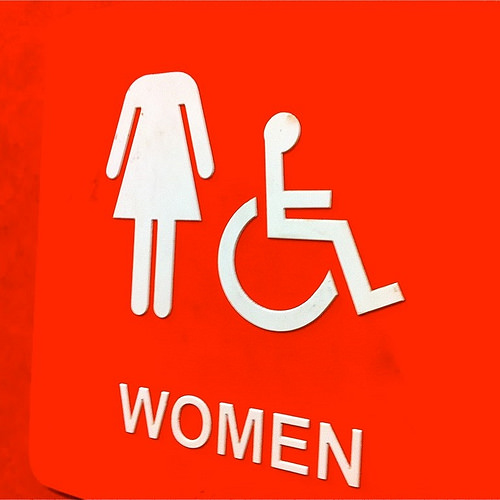<image>
Can you confirm if the headless woman is on the sign? Yes. Looking at the image, I can see the headless woman is positioned on top of the sign, with the sign providing support. Is there a headless woman next to the wheelchair? Yes. The headless woman is positioned adjacent to the wheelchair, located nearby in the same general area. 